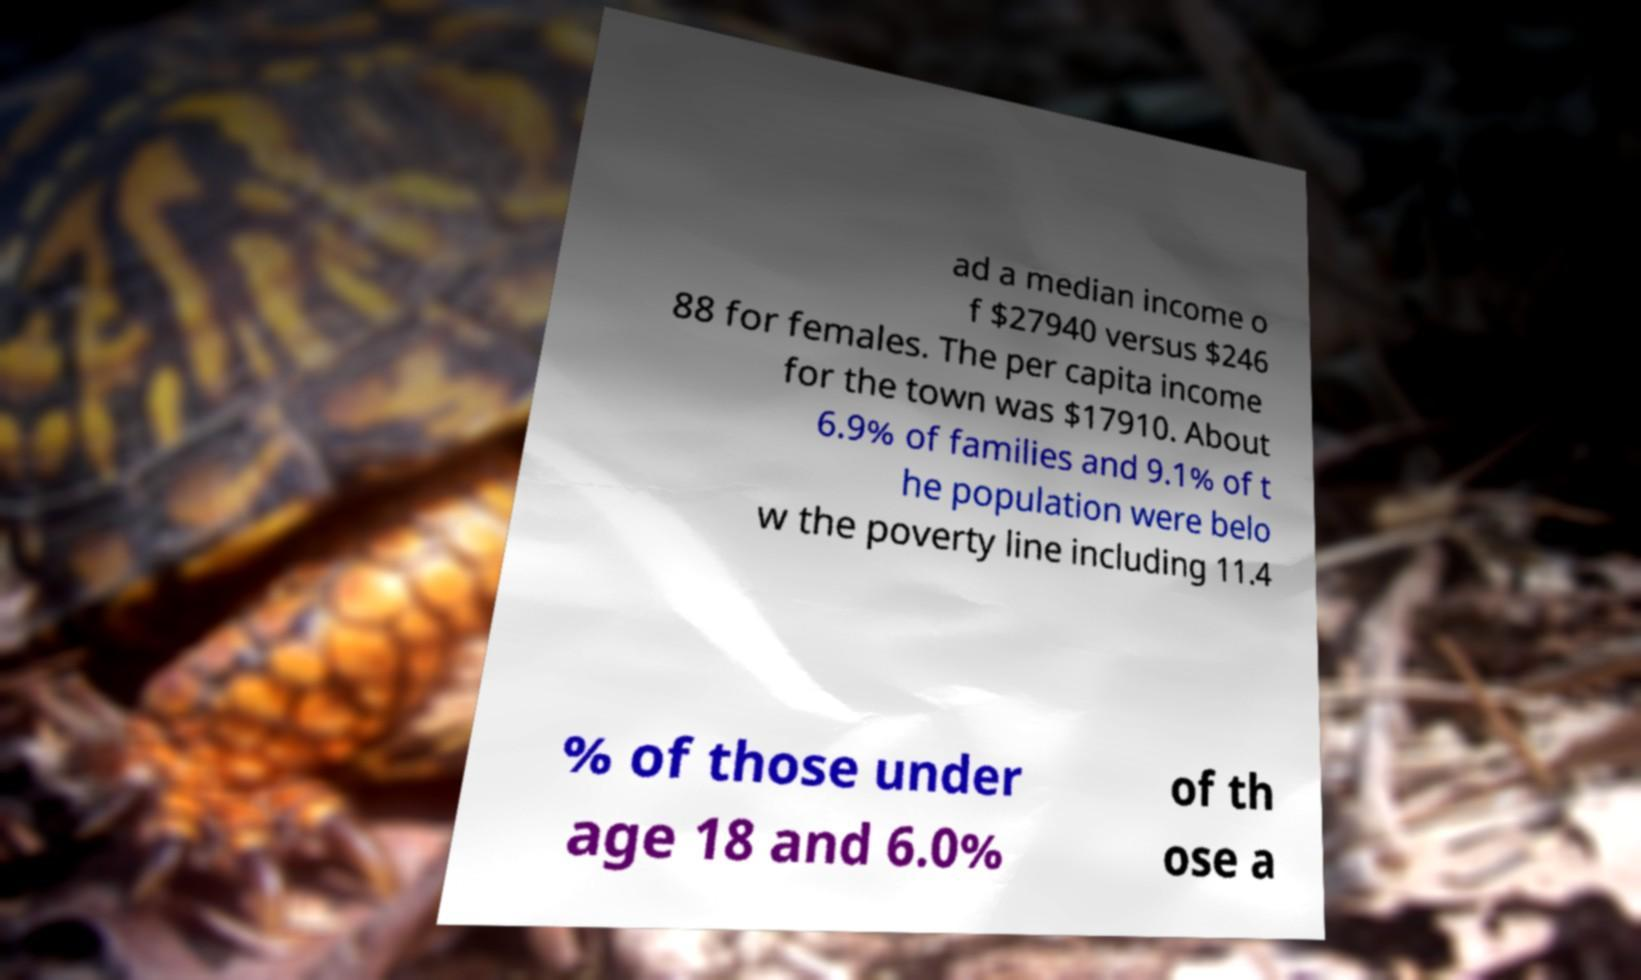Could you assist in decoding the text presented in this image and type it out clearly? ad a median income o f $27940 versus $246 88 for females. The per capita income for the town was $17910. About 6.9% of families and 9.1% of t he population were belo w the poverty line including 11.4 % of those under age 18 and 6.0% of th ose a 